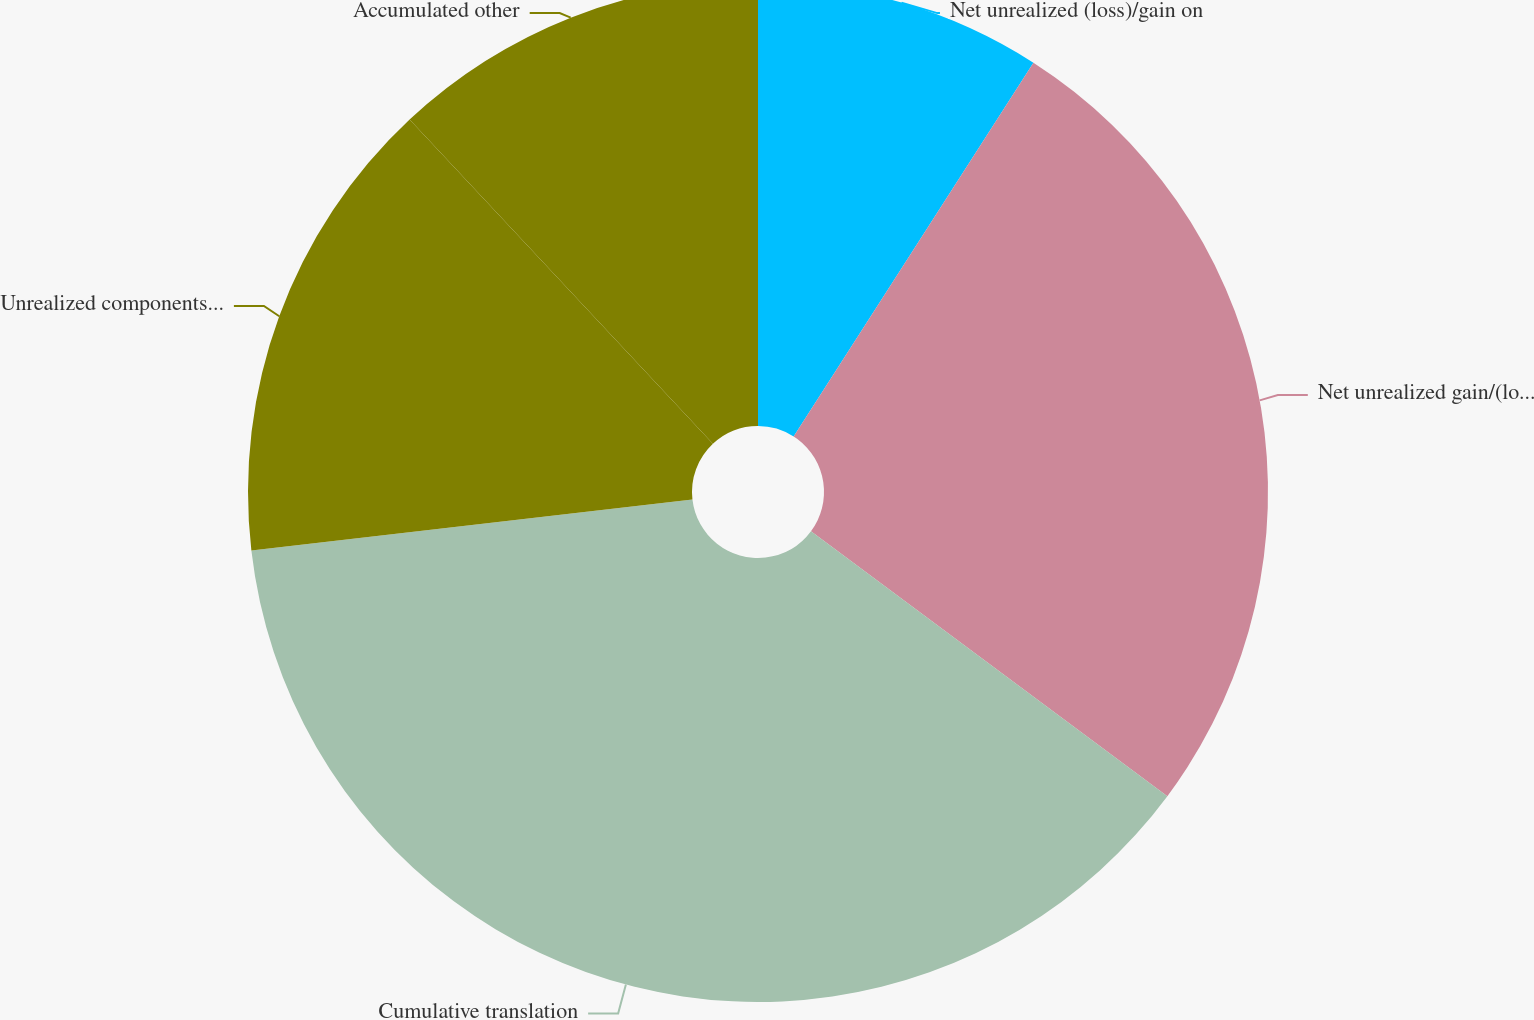Convert chart to OTSL. <chart><loc_0><loc_0><loc_500><loc_500><pie_chart><fcel>Net unrealized (loss)/gain on<fcel>Net unrealized gain/(loss) on<fcel>Cumulative translation<fcel>Unrealized components of<fcel>Accumulated other<nl><fcel>9.08%<fcel>26.09%<fcel>38.0%<fcel>14.86%<fcel>11.97%<nl></chart> 